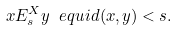Convert formula to latex. <formula><loc_0><loc_0><loc_500><loc_500>x E ^ { X } _ { s } y \ e q u i d ( x , y ) < s .</formula> 